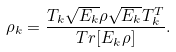Convert formula to latex. <formula><loc_0><loc_0><loc_500><loc_500>\rho _ { k } = \frac { T _ { k } \sqrt { E _ { k } } \rho \sqrt { E _ { k } } T _ { k } ^ { T } } { T r [ E _ { k } \rho ] } .</formula> 